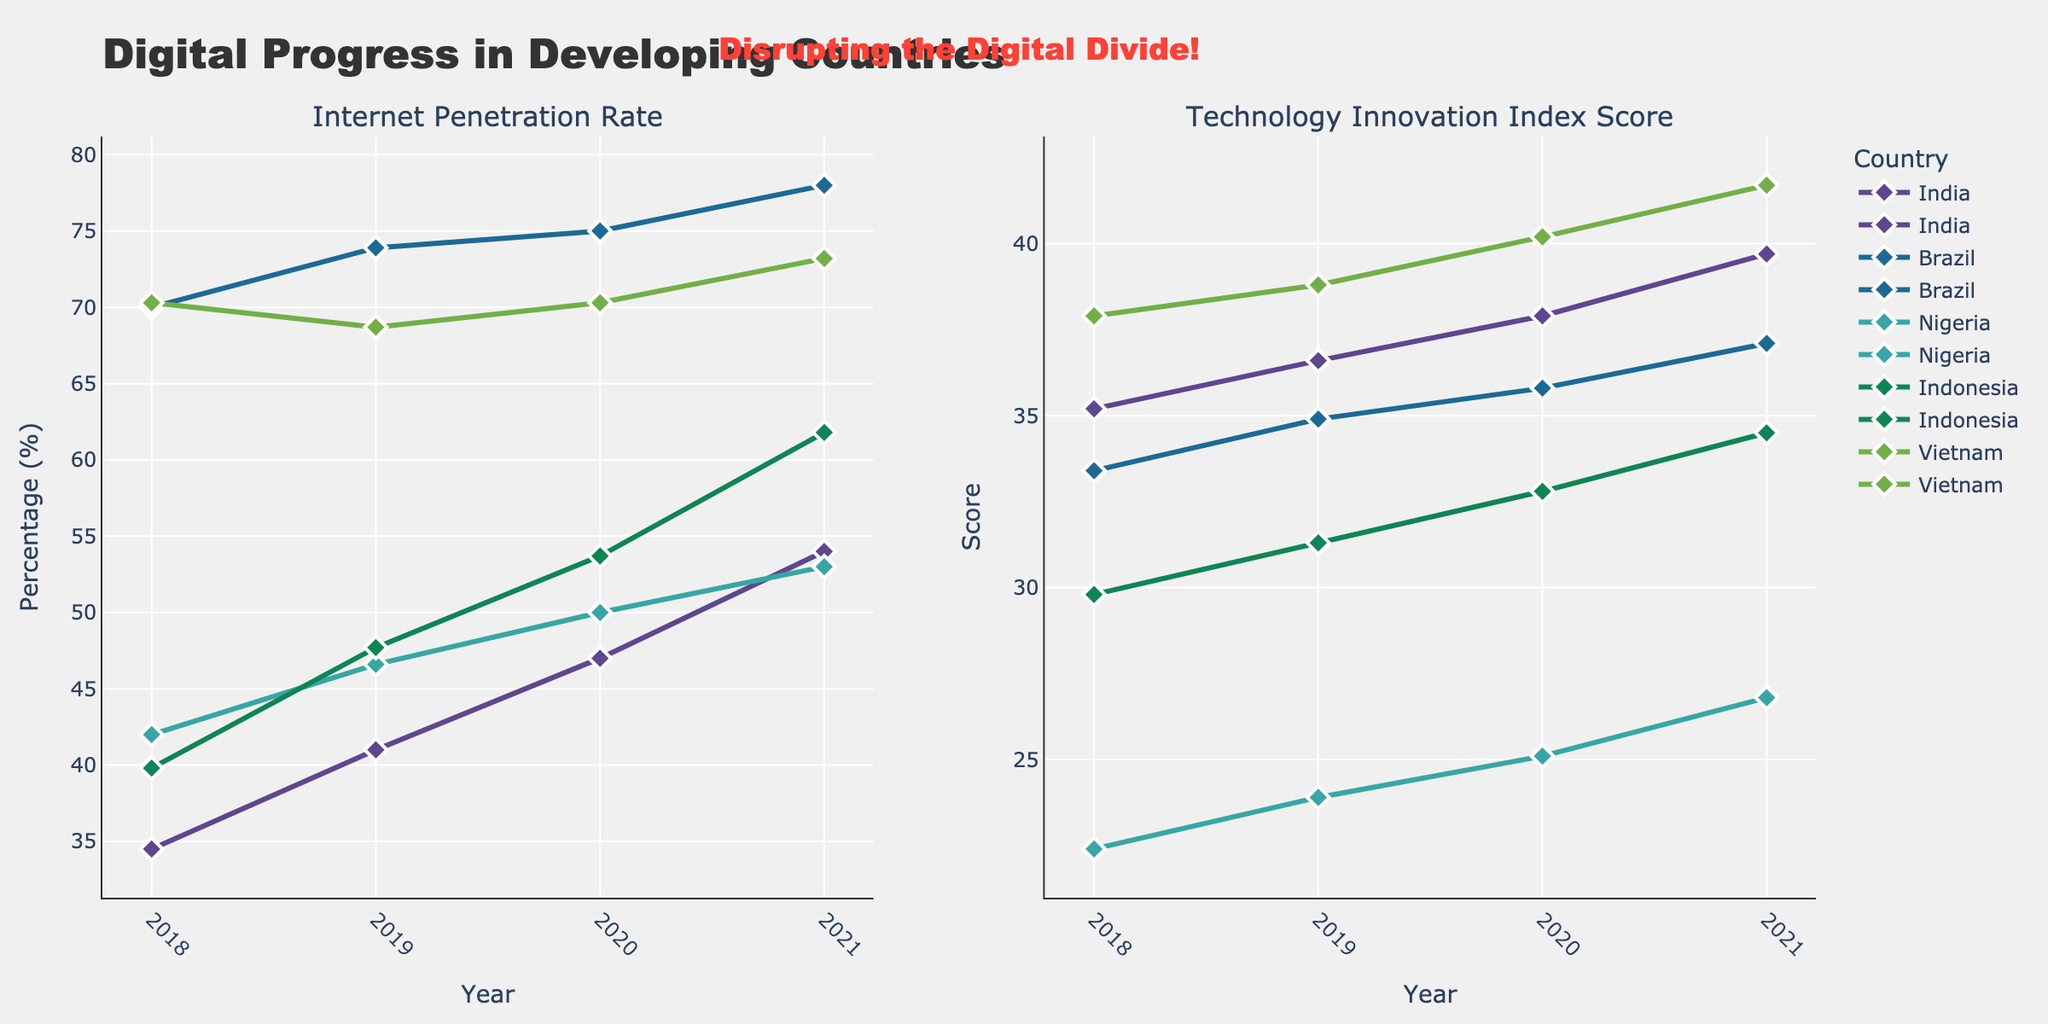How did India's Internet Penetration Rate change from 2018 to 2021? First, locate India's Internet Penetration Rate for the years 2018 and 2021 on the left subplot. In 2018, it was 34.5%, and in 2021, it was 54.0%. The change is calculated by subtracting the 2018 value from the 2021 value: 54.0% - 34.5% = 19.5%.
Answer: 19.5% Which country had the highest Technology Innovation Index Score in 2021? Check the right subplot for the year 2021. Compare the Technology Innovation Index Scores for all the countries. Vietnam had the highest score with 41.7.
Answer: Vietnam What is the average Internet Penetration Rate for Indonesia over the years shown? Identify Indonesia's Internet Penetration Rates for 2018, 2019, 2020, and 2021: 39.8%, 47.7%, 53.7%, and 61.8%. Sum these values: 39.8 + 47.7 + 53.7 + 61.8 = 203. Then, divide the sum by 4 (number of years): 203 / 4 = 50.75%.
Answer: 50.75% Between Brazil and Nigeria, which country had a higher increase in Technology Innovation Index Score from 2018 to 2021? Identify the initial and final Technology Innovation Index Scores for Brazil and Nigeria. Brazil (2018): 33.4, (2021): 37.1; Nigeria (2018): 22.4, (2021): 26.8. Calculate the increase: Brazil: 37.1 - 33.4 = 3.7, Nigeria: 26.8 - 22.4 = 4.4. Nigeria had a higher increase (4.4).
Answer: Nigeria Which country shows the most visually steep rise in Internet Penetration Rate? Assess the slope of the lines in the left subplot. Indonesia displays a visibly steep rise from 2018 to 2021.
Answer: Indonesia What is the difference between Vietnam's Technology Innovation Index Score in 2018 and its Internet Penetration Rate in the same year? Look at Vietnam's values for 2018 in both subplots. The Technology Innovation Index Score is 37.9, and the Internet Penetration Rate is 70.3%. Compute the difference: 70.3% - 37.9 = 32.4%.
Answer: 32.4% Did any country have a drop in Technology Innovation Index Score from one year to the next? Check the right subplot for any countries where the score decreases from one year to the next. Vietnam had a decrease from 2018 to 2019, from 37.9 to 38.8.
Answer: No 